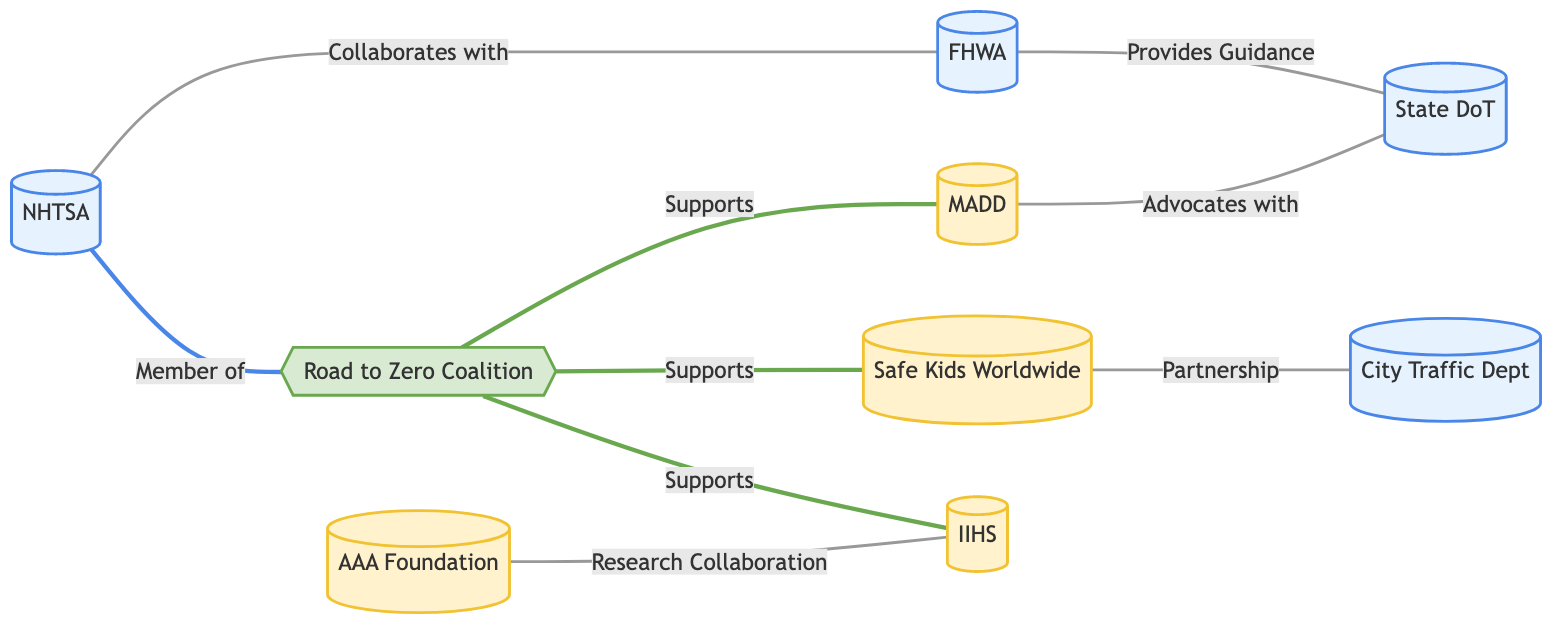What organization collaborates with the NHTSA? The diagram shows a connection between NHTSA (node 1) and FHWA (node 2), indicating a collaboration.
Answer: FHWA What type of organization is the Road to Zero Coalition? The Road to Zero Coalition is represented as a coalition in the diagram, as denoted by its grouping and style.
Answer: Coalition How many nodes are represented in the diagram? By counting the nodes listed in the data provided, there are a total of 9 unique organizations represented.
Answer: 9 What relationship does MADD have with the State Department of Transportation? MADD advocates with the State Department of Transportation, as indicated by the connecting edge labeled "Advocates with."
Answer: Advocates with Which organization supports both Safe Kids Worldwide and IIHS? The Road to Zero Coalition is identified as supporting both Safe Kids Worldwide (node 4) and IIHS (node 8).
Answer: Road to Zero Coalition How many relationships does the NHTSA have in the diagram? The NHTSA has two explicit relationships in the diagram - collaborating with FHWA and being a member of the Road to Zero Coalition.
Answer: 2 Which organization has a research collaboration with the Insurance Institute for Highway Safety? The diagram shows that the AAA Foundation for Traffic Safety has a research collaboration with IIHS, as indicated by the labeled edge.
Answer: AAA Foundation for Traffic Safety What connection exists between the Federal Highway Administration and the State Department of Transportation? The diagram indicates that the Federal Highway Administration provides guidance to the State Department of Transportation, denoted by the labeled edge connecting the two.
Answer: Provides Guidance Which organization has partnerships with local government traffic departments? Safe Kids Worldwide has a partnership with the City Traffic Department, as shown by the connection labeled "Partnership."
Answer: Safe Kids Worldwide 